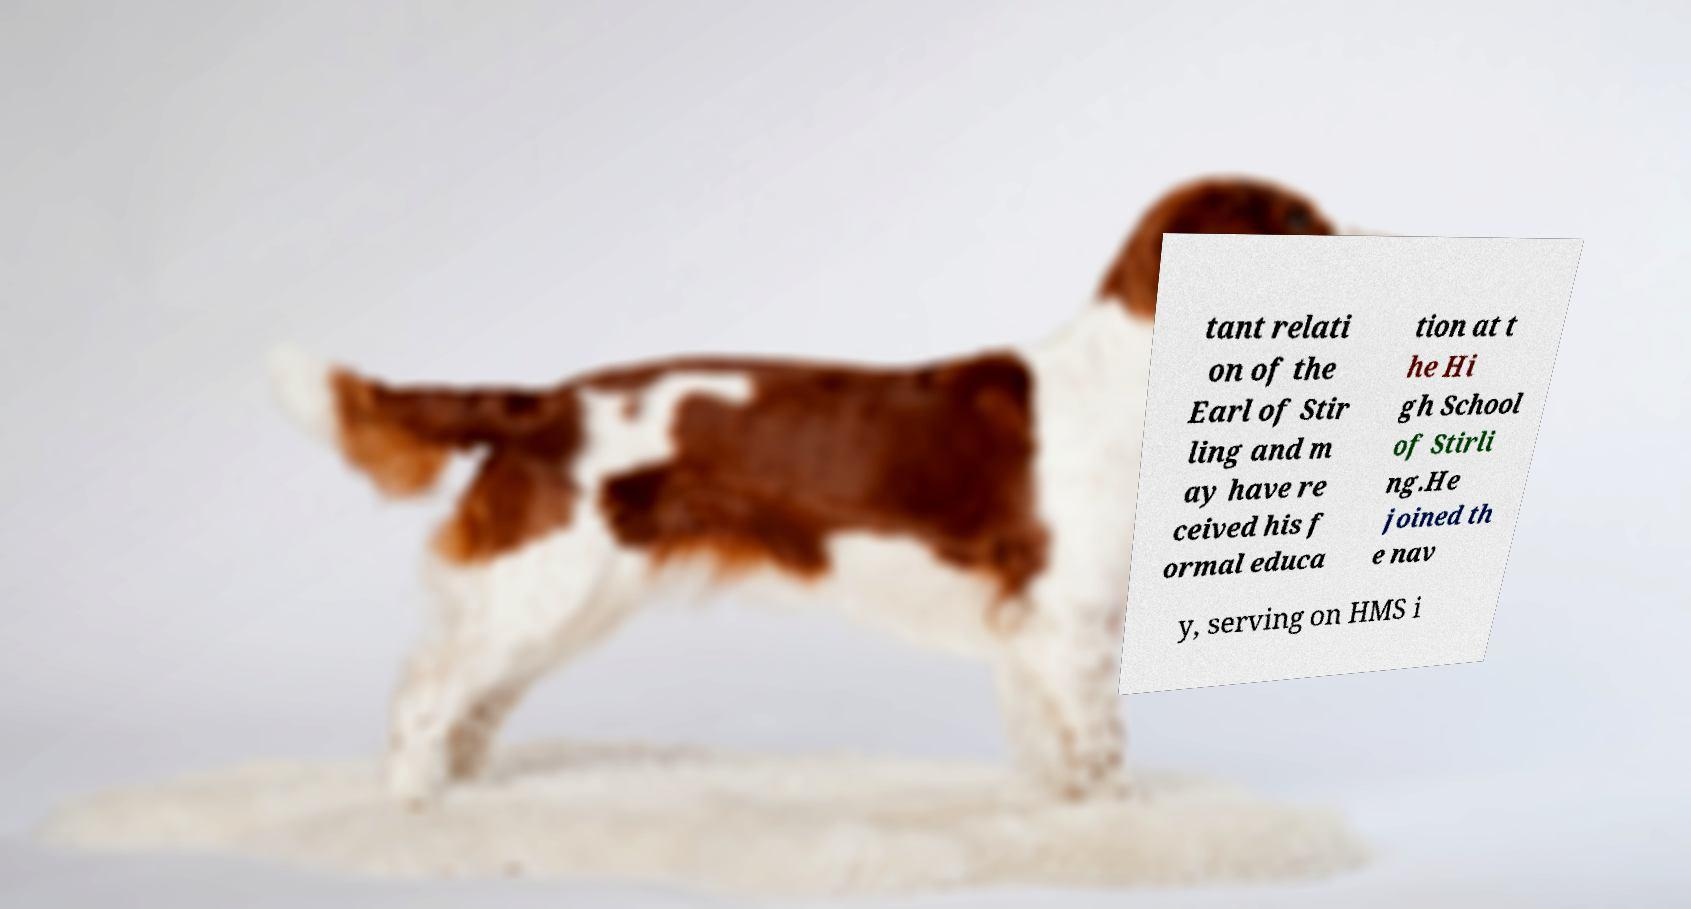Could you extract and type out the text from this image? tant relati on of the Earl of Stir ling and m ay have re ceived his f ormal educa tion at t he Hi gh School of Stirli ng.He joined th e nav y, serving on HMS i 